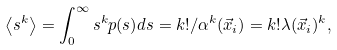Convert formula to latex. <formula><loc_0><loc_0><loc_500><loc_500>\left < s ^ { k } \right > = \int ^ { \infty } _ { 0 } s ^ { k } p ( s ) d s = k ! / \alpha ^ { k } ( \vec { x } _ { i } ) = k ! \lambda ( \vec { x } _ { i } ) ^ { k } ,</formula> 